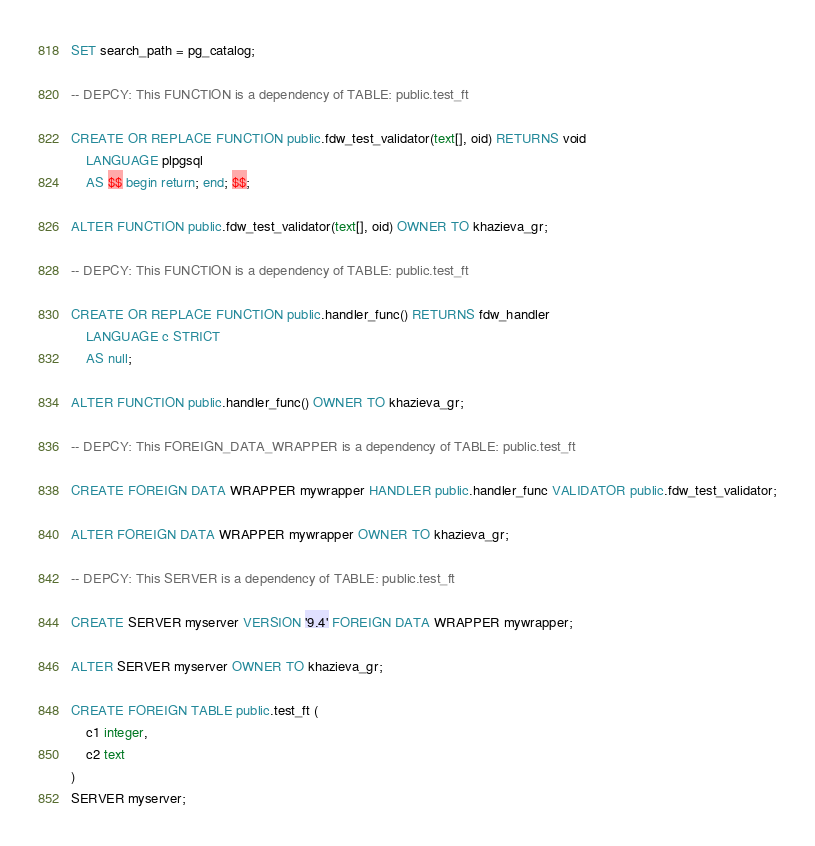Convert code to text. <code><loc_0><loc_0><loc_500><loc_500><_SQL_>SET search_path = pg_catalog;

-- DEPCY: This FUNCTION is a dependency of TABLE: public.test_ft

CREATE OR REPLACE FUNCTION public.fdw_test_validator(text[], oid) RETURNS void
    LANGUAGE plpgsql
    AS $$ begin return; end; $$;

ALTER FUNCTION public.fdw_test_validator(text[], oid) OWNER TO khazieva_gr;

-- DEPCY: This FUNCTION is a dependency of TABLE: public.test_ft

CREATE OR REPLACE FUNCTION public.handler_func() RETURNS fdw_handler
    LANGUAGE c STRICT
    AS null;

ALTER FUNCTION public.handler_func() OWNER TO khazieva_gr;

-- DEPCY: This FOREIGN_DATA_WRAPPER is a dependency of TABLE: public.test_ft

CREATE FOREIGN DATA WRAPPER mywrapper HANDLER public.handler_func VALIDATOR public.fdw_test_validator;

ALTER FOREIGN DATA WRAPPER mywrapper OWNER TO khazieva_gr;

-- DEPCY: This SERVER is a dependency of TABLE: public.test_ft

CREATE SERVER myserver VERSION '9.4' FOREIGN DATA WRAPPER mywrapper;

ALTER SERVER myserver OWNER TO khazieva_gr;

CREATE FOREIGN TABLE public.test_ft (
	c1 integer,
	c2 text
)
SERVER myserver;</code> 